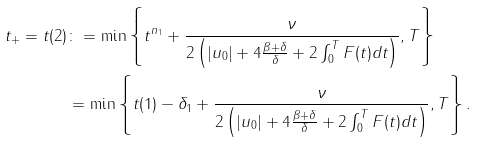<formula> <loc_0><loc_0><loc_500><loc_500>t _ { + } = t ( 2 ) & \colon = \min \left \{ t ^ { n _ { 1 } } + \frac { \nu } { 2 \left ( | u _ { 0 } | + 4 \frac { \beta + \delta } { \delta } + 2 \int _ { 0 } ^ { T } F ( t ) d t \right ) } , T \right \} \\ & = \min \left \{ t ( 1 ) - \delta _ { 1 } + \frac { \nu } { 2 \left ( | u _ { 0 } | + 4 \frac { \beta + \delta } { \delta } + 2 \int _ { 0 } ^ { T } F ( t ) d t \right ) } , T \right \} .</formula> 